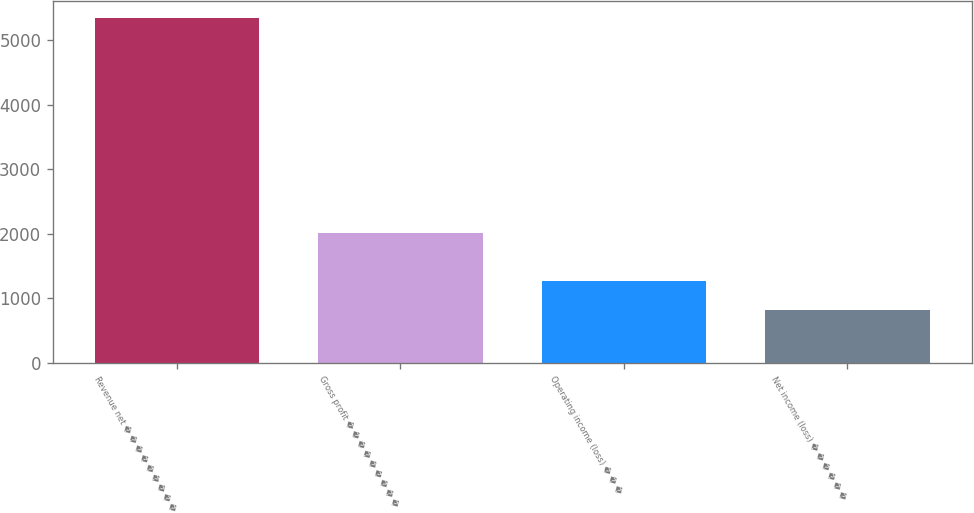Convert chart. <chart><loc_0><loc_0><loc_500><loc_500><bar_chart><fcel>Revenue net � � � � � � � � �<fcel>Gross profit � � � � � � � � �<fcel>Operating income (loss) � � �<fcel>Net income (loss) � � � � � �<nl><fcel>5336<fcel>2013<fcel>1274.3<fcel>823<nl></chart> 